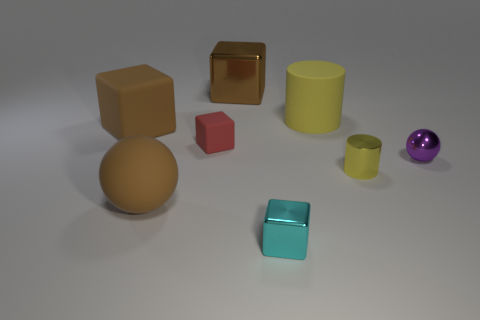Is there anything else that has the same color as the tiny metallic ball?
Offer a terse response. No. There is a brown cube that is behind the brown rubber thing on the left side of the brown matte sphere; how many big blocks are to the left of it?
Your response must be concise. 1. There is a object that is both in front of the purple thing and behind the big sphere; what is its material?
Your answer should be compact. Metal. Is the material of the tiny sphere the same as the ball in front of the metallic cylinder?
Your answer should be compact. No. Is the number of brown blocks behind the small purple metallic thing greater than the number of shiny cylinders behind the big metal block?
Keep it short and to the point. Yes. What shape is the big brown metal object?
Offer a very short reply. Cube. Is the large yellow object behind the small yellow metallic object made of the same material as the object that is in front of the big brown sphere?
Your answer should be compact. No. What is the shape of the shiny thing behind the big yellow thing?
Offer a terse response. Cube. There is a red object that is the same shape as the cyan thing; what is its size?
Provide a succinct answer. Small. Do the metallic cylinder and the large cylinder have the same color?
Your answer should be compact. Yes. 